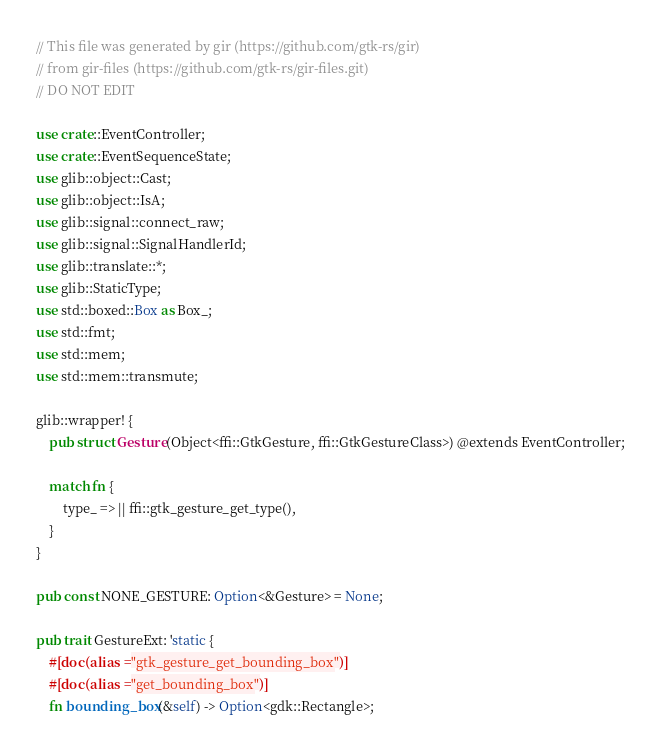Convert code to text. <code><loc_0><loc_0><loc_500><loc_500><_Rust_>// This file was generated by gir (https://github.com/gtk-rs/gir)
// from gir-files (https://github.com/gtk-rs/gir-files.git)
// DO NOT EDIT

use crate::EventController;
use crate::EventSequenceState;
use glib::object::Cast;
use glib::object::IsA;
use glib::signal::connect_raw;
use glib::signal::SignalHandlerId;
use glib::translate::*;
use glib::StaticType;
use std::boxed::Box as Box_;
use std::fmt;
use std::mem;
use std::mem::transmute;

glib::wrapper! {
    pub struct Gesture(Object<ffi::GtkGesture, ffi::GtkGestureClass>) @extends EventController;

    match fn {
        type_ => || ffi::gtk_gesture_get_type(),
    }
}

pub const NONE_GESTURE: Option<&Gesture> = None;

pub trait GestureExt: 'static {
    #[doc(alias = "gtk_gesture_get_bounding_box")]
    #[doc(alias = "get_bounding_box")]
    fn bounding_box(&self) -> Option<gdk::Rectangle>;
</code> 